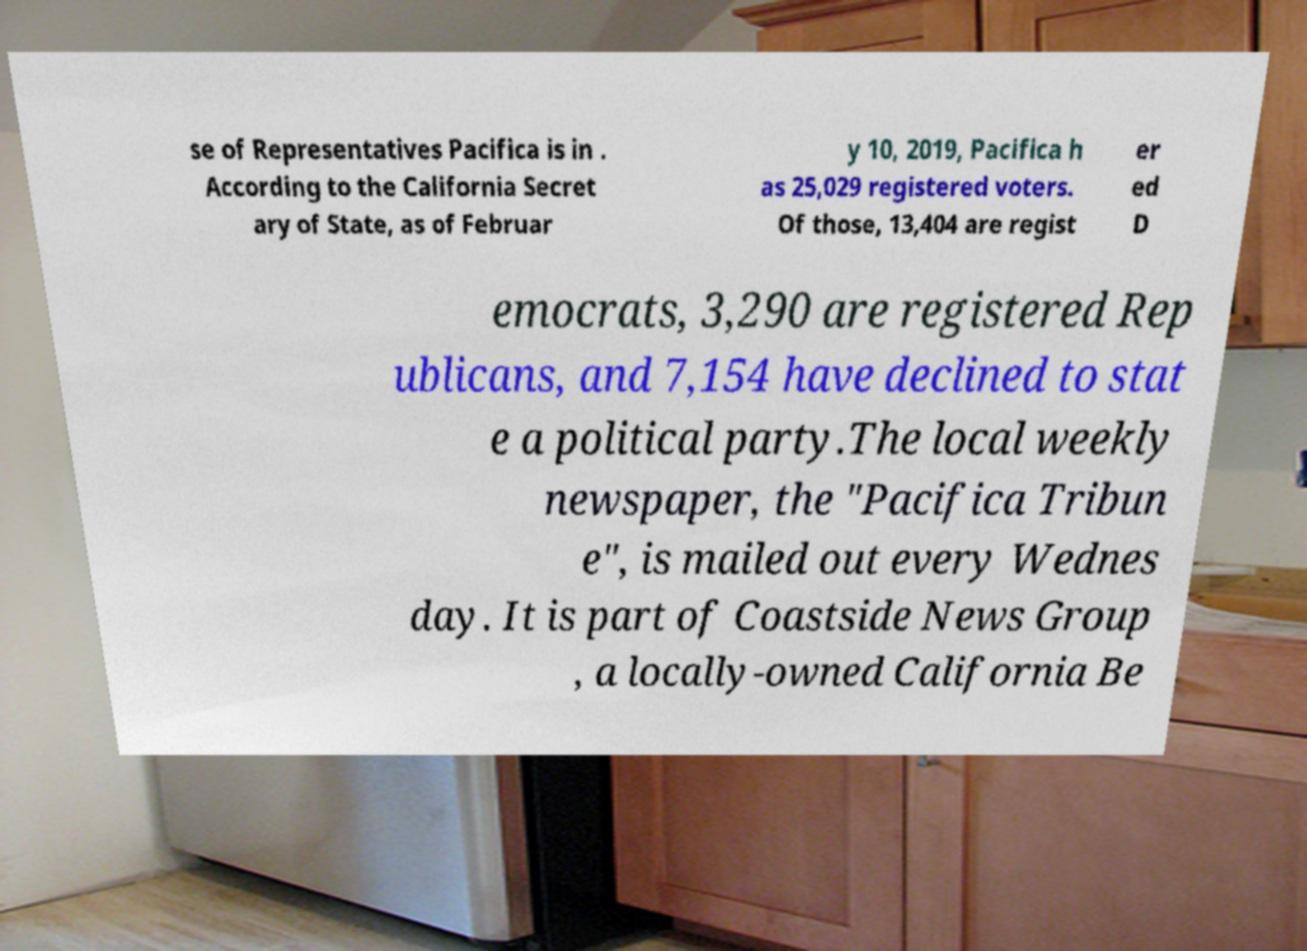Can you accurately transcribe the text from the provided image for me? se of Representatives Pacifica is in . According to the California Secret ary of State, as of Februar y 10, 2019, Pacifica h as 25,029 registered voters. Of those, 13,404 are regist er ed D emocrats, 3,290 are registered Rep ublicans, and 7,154 have declined to stat e a political party.The local weekly newspaper, the "Pacifica Tribun e", is mailed out every Wednes day. It is part of Coastside News Group , a locally-owned California Be 